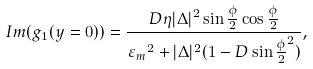Convert formula to latex. <formula><loc_0><loc_0><loc_500><loc_500>I m ( { g _ { 1 } } ( y = 0 ) ) = \frac { D \eta | \Delta | ^ { 2 } \sin { \frac { \phi } { 2 } } \cos { \frac { \phi } { 2 } } } { { \varepsilon _ { m } } ^ { 2 } + | \Delta | ^ { 2 } ( 1 - D \sin { \frac { \phi } { 2 } } ^ { 2 } ) } ,</formula> 